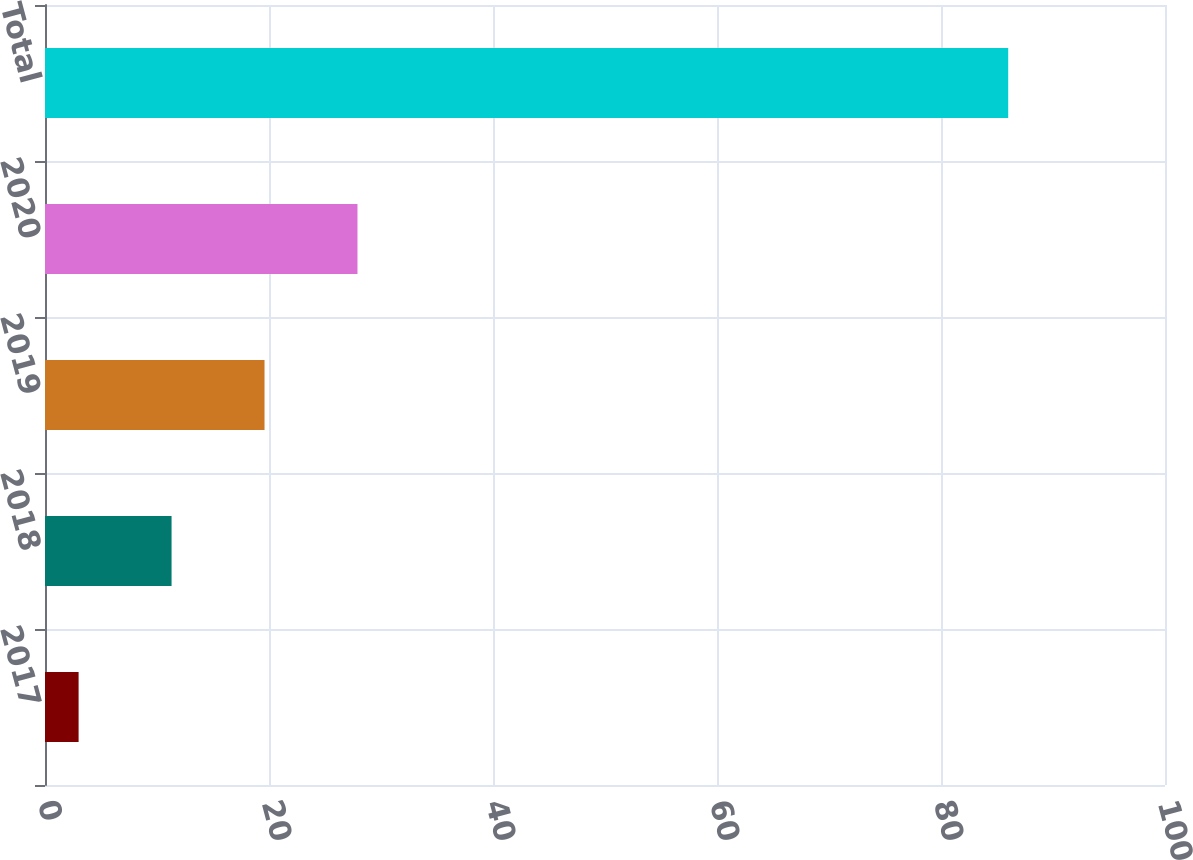Convert chart to OTSL. <chart><loc_0><loc_0><loc_500><loc_500><bar_chart><fcel>2017<fcel>2018<fcel>2019<fcel>2020<fcel>Total<nl><fcel>3<fcel>11.3<fcel>19.6<fcel>27.9<fcel>86<nl></chart> 